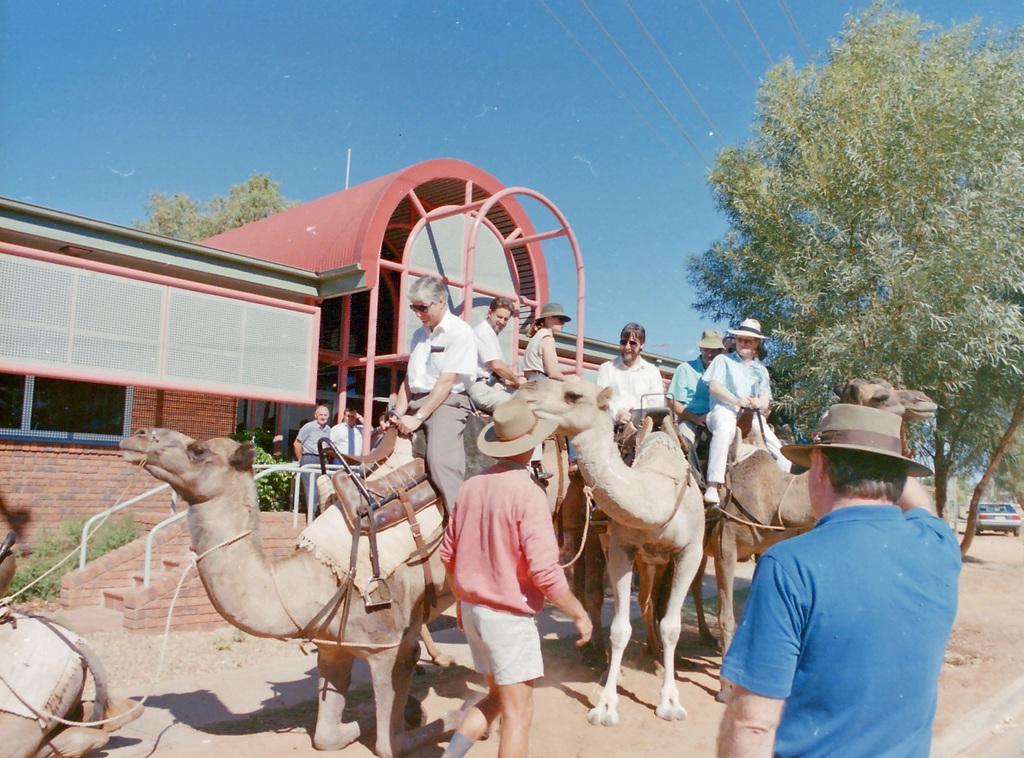Please provide a concise description of this image. In this image I can see the group of people with different color dresses and few people with the hats. I can see few people are sitting on the camels and few people are standing. In the background I can see the shed, many trees and the blue sky. 